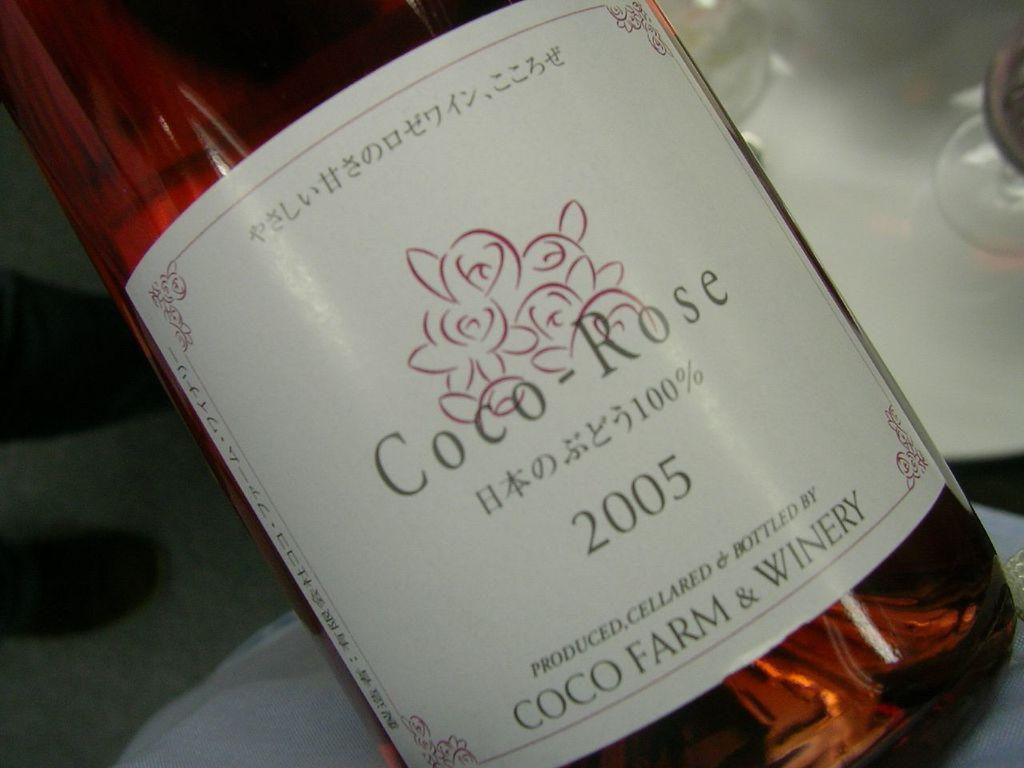<image>
Write a terse but informative summary of the picture. a bottle of wine with a label on it that says 'coco-rose' 